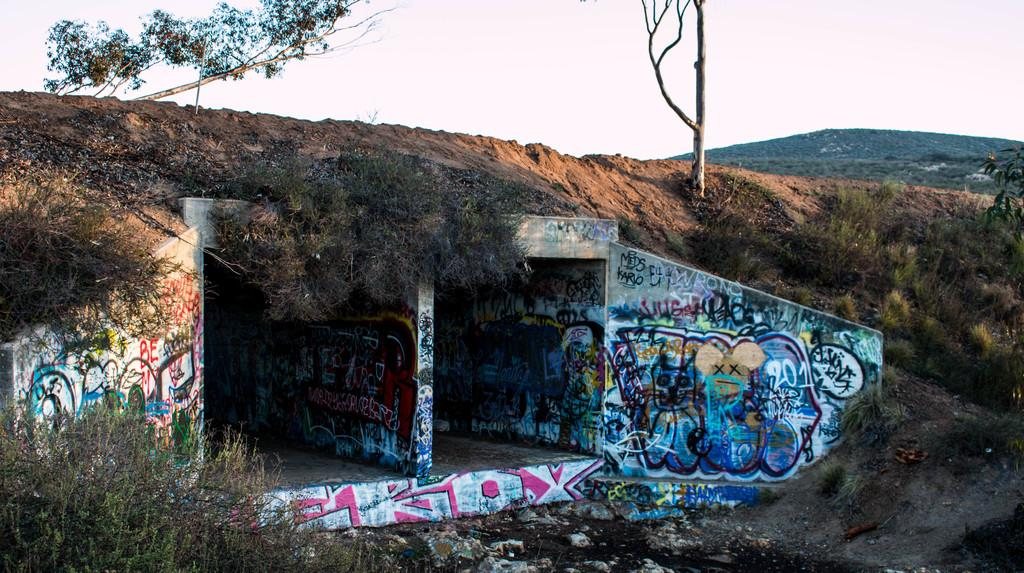Provide a one-sentence caption for the provided image. An old tunnel is painted with Graffitu with the numbers 201. 